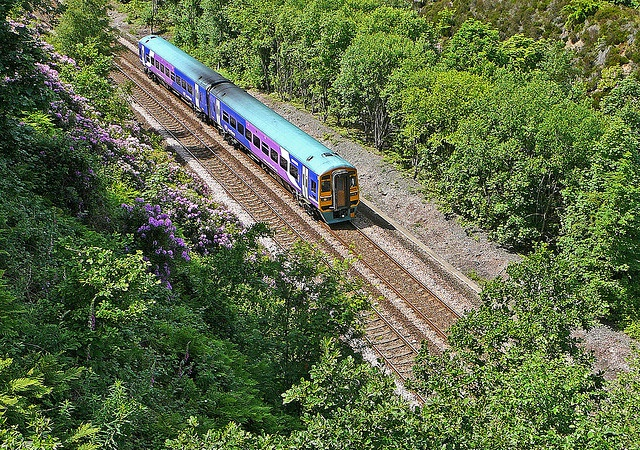Describe the objects in this image and their specific colors. I can see a train in darkgreen, lightblue, black, white, and gray tones in this image. 